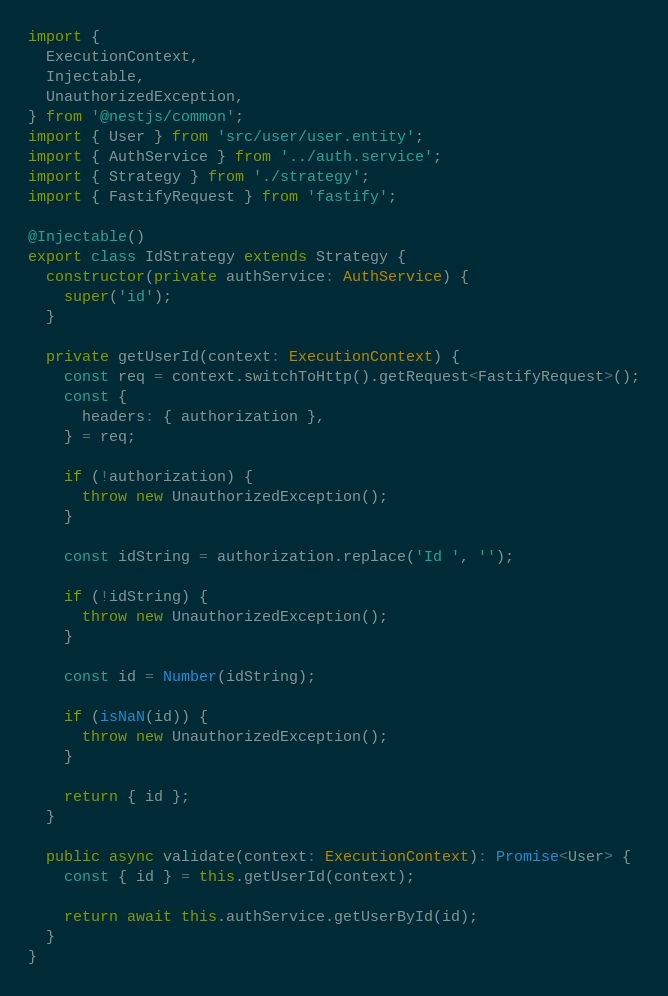<code> <loc_0><loc_0><loc_500><loc_500><_TypeScript_>import {
  ExecutionContext,
  Injectable,
  UnauthorizedException,
} from '@nestjs/common';
import { User } from 'src/user/user.entity';
import { AuthService } from '../auth.service';
import { Strategy } from './strategy';
import { FastifyRequest } from 'fastify';

@Injectable()
export class IdStrategy extends Strategy {
  constructor(private authService: AuthService) {
    super('id');
  }

  private getUserId(context: ExecutionContext) {
    const req = context.switchToHttp().getRequest<FastifyRequest>();
    const {
      headers: { authorization },
    } = req;

    if (!authorization) {
      throw new UnauthorizedException();
    }

    const idString = authorization.replace('Id ', '');

    if (!idString) {
      throw new UnauthorizedException();
    }

    const id = Number(idString);

    if (isNaN(id)) {
      throw new UnauthorizedException();
    }

    return { id };
  }

  public async validate(context: ExecutionContext): Promise<User> {
    const { id } = this.getUserId(context);

    return await this.authService.getUserById(id);
  }
}
</code> 